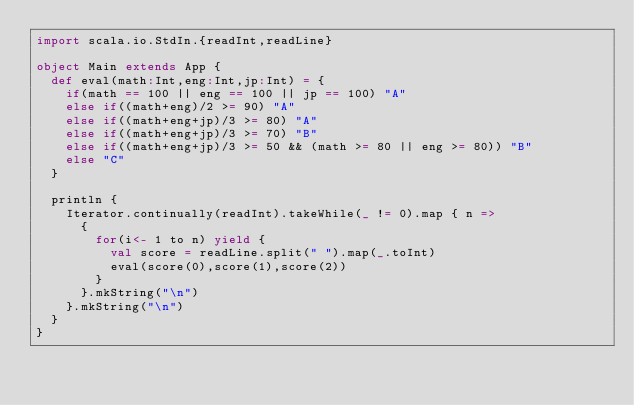Convert code to text. <code><loc_0><loc_0><loc_500><loc_500><_Scala_>import scala.io.StdIn.{readInt,readLine}

object Main extends App {
  def eval(math:Int,eng:Int,jp:Int) = {
    if(math == 100 || eng == 100 || jp == 100) "A"
    else if((math+eng)/2 >= 90) "A"
    else if((math+eng+jp)/3 >= 80) "A"
    else if((math+eng+jp)/3 >= 70) "B"
    else if((math+eng+jp)/3 >= 50 && (math >= 80 || eng >= 80)) "B"
    else "C"
  }

  println {
    Iterator.continually(readInt).takeWhile(_ != 0).map { n =>
      {
        for(i<- 1 to n) yield {
          val score = readLine.split(" ").map(_.toInt)
          eval(score(0),score(1),score(2))
        }
      }.mkString("\n")
    }.mkString("\n")
  }
}</code> 